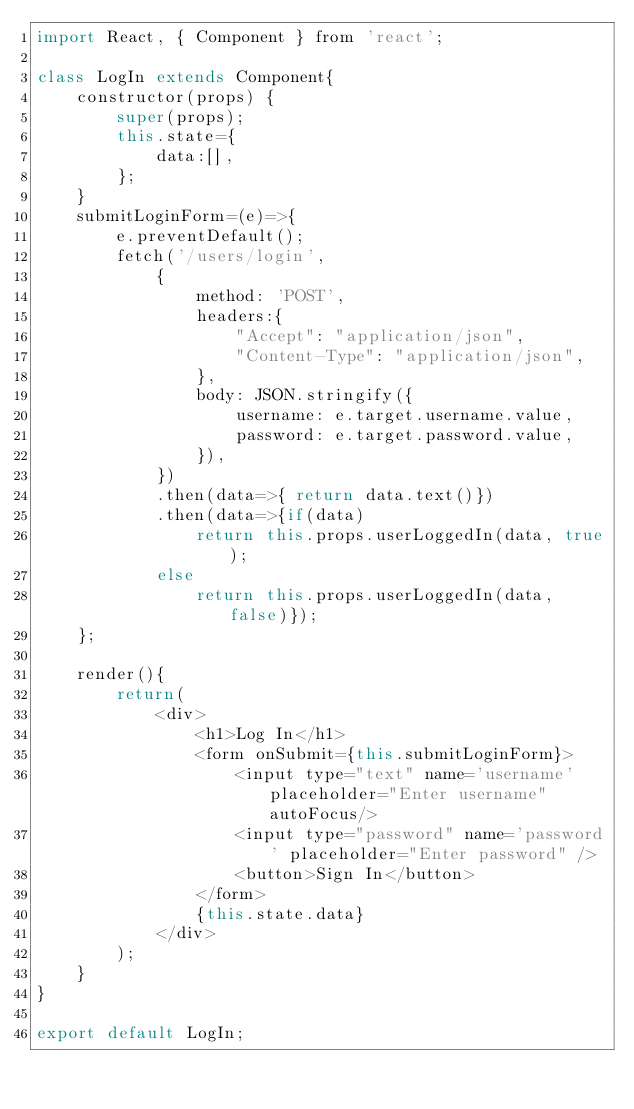<code> <loc_0><loc_0><loc_500><loc_500><_JavaScript_>import React, { Component } from 'react';

class LogIn extends Component{
    constructor(props) {
        super(props);
        this.state={
            data:[],
        };
    }
    submitLoginForm=(e)=>{
        e.preventDefault();
        fetch('/users/login',
            {
                method: 'POST',
                headers:{
                    "Accept": "application/json",
                    "Content-Type": "application/json",
                },
                body: JSON.stringify({
                    username: e.target.username.value,
                    password: e.target.password.value,
                }),
            })
            .then(data=>{ return data.text()})
            .then(data=>{if(data)
                return this.props.userLoggedIn(data, true);
            else
                return this.props.userLoggedIn(data, false)});
    };

    render(){
        return(
            <div>
                <h1>Log In</h1>
                <form onSubmit={this.submitLoginForm}>
                    <input type="text" name='username' placeholder="Enter username" autoFocus/>
                    <input type="password" name='password' placeholder="Enter password" />
                    <button>Sign In</button>
                </form>
                {this.state.data}
            </div>
        );
    }
}

export default LogIn;</code> 